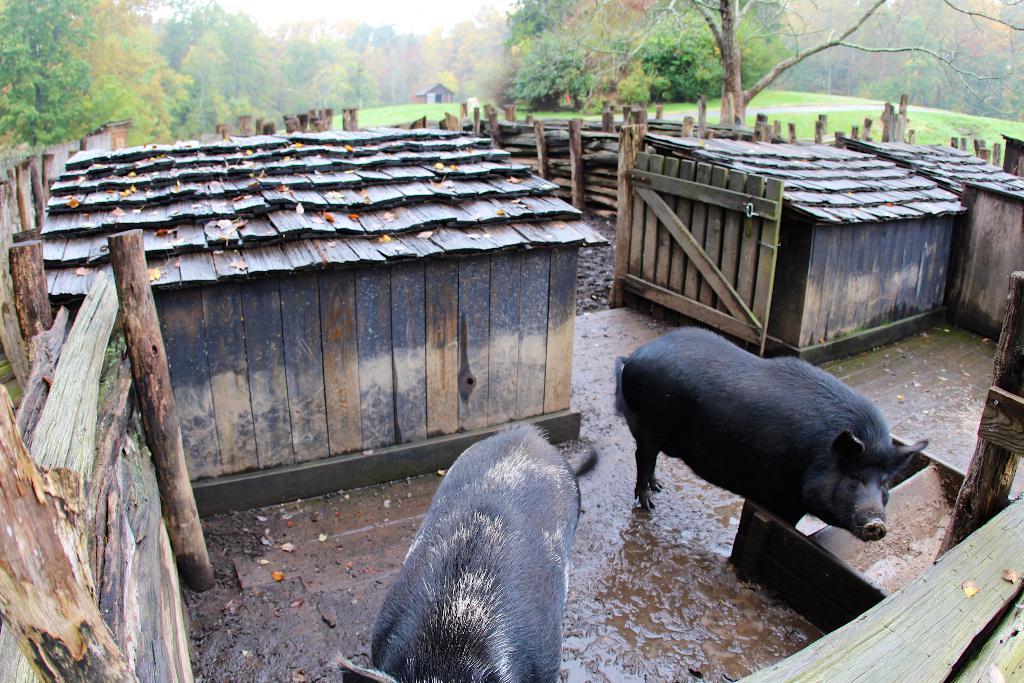How would you summarize this image in a sentence or two? In the foreground of the image we can see two pigs on the ground and some wood pieces and a container placed on the ground. In the center of the image we can see a gate, buildings with roofs, group of wood logs. In the background, we can see a group of trees, building and the sky. 